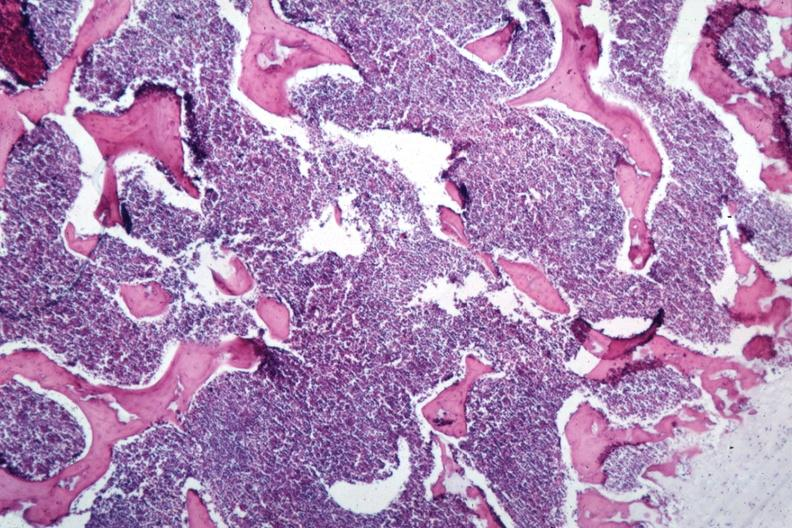s hematologic present?
Answer the question using a single word or phrase. Yes 